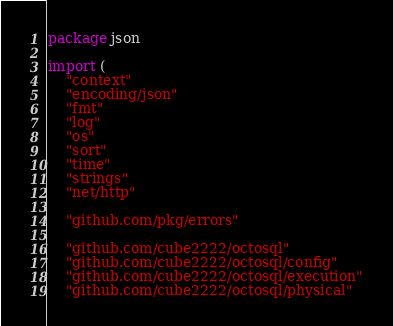Convert code to text. <code><loc_0><loc_0><loc_500><loc_500><_Go_>package json

import (
	"context"
	"encoding/json"
	"fmt"
	"log"
	"os"
	"sort"
	"time"
	"strings"
	"net/http"

	"github.com/pkg/errors"

	"github.com/cube2222/octosql"
	"github.com/cube2222/octosql/config"
	"github.com/cube2222/octosql/execution"
	"github.com/cube2222/octosql/physical"</code> 